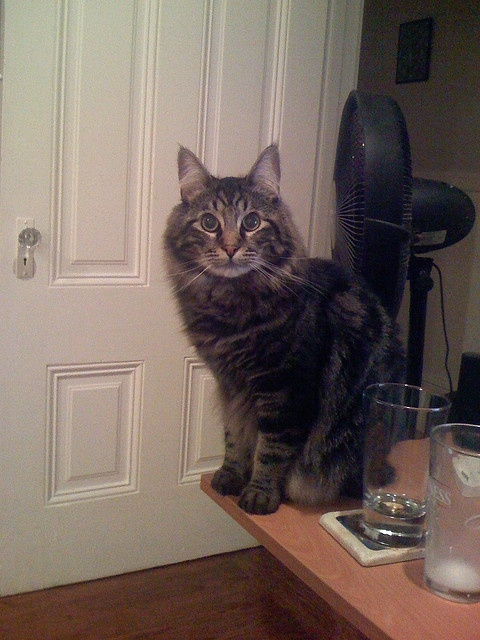Describe the objects in this image and their specific colors. I can see cat in gray and black tones, cup in gray, black, and brown tones, and cup in gray and darkgray tones in this image. 